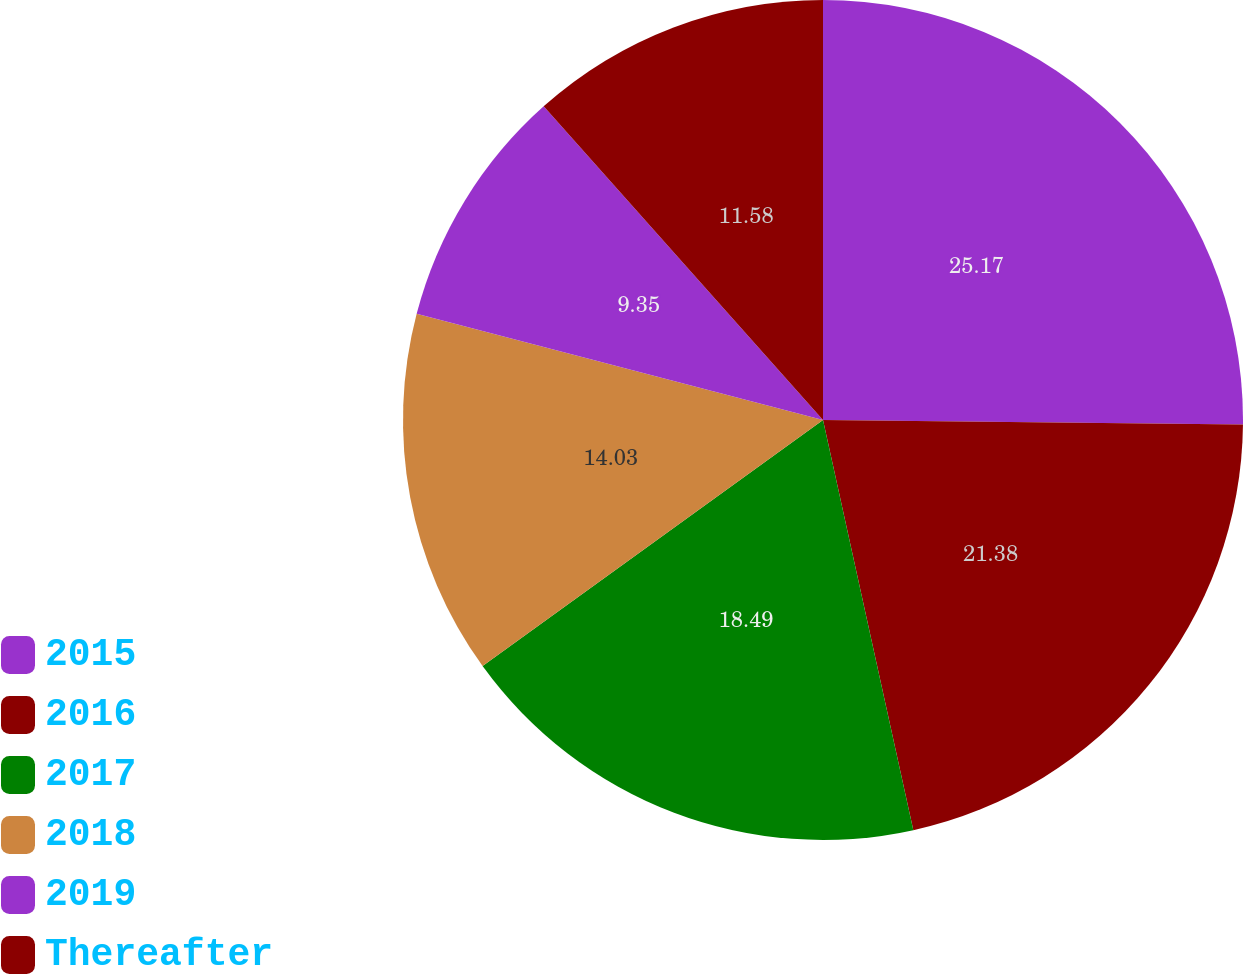Convert chart to OTSL. <chart><loc_0><loc_0><loc_500><loc_500><pie_chart><fcel>2015<fcel>2016<fcel>2017<fcel>2018<fcel>2019<fcel>Thereafter<nl><fcel>25.17%<fcel>21.38%<fcel>18.49%<fcel>14.03%<fcel>9.35%<fcel>11.58%<nl></chart> 